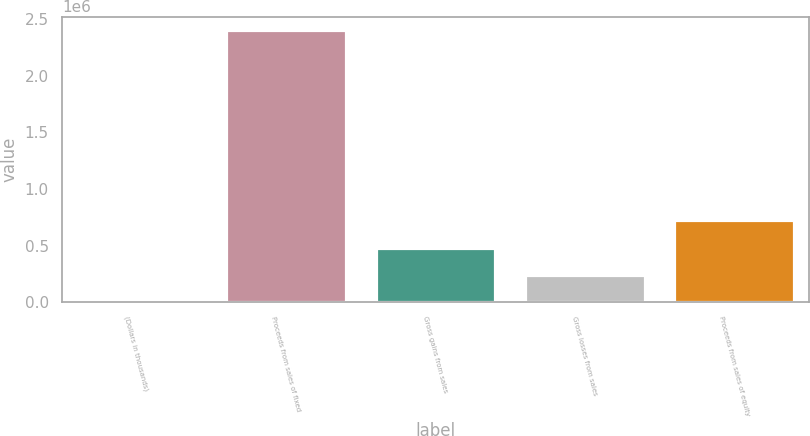<chart> <loc_0><loc_0><loc_500><loc_500><bar_chart><fcel>(Dollars in thousands)<fcel>Proceeds from sales of fixed<fcel>Gross gains from sales<fcel>Gross losses from sales<fcel>Proceeds from sales of equity<nl><fcel>2017<fcel>2.40184e+06<fcel>481982<fcel>242000<fcel>721965<nl></chart> 